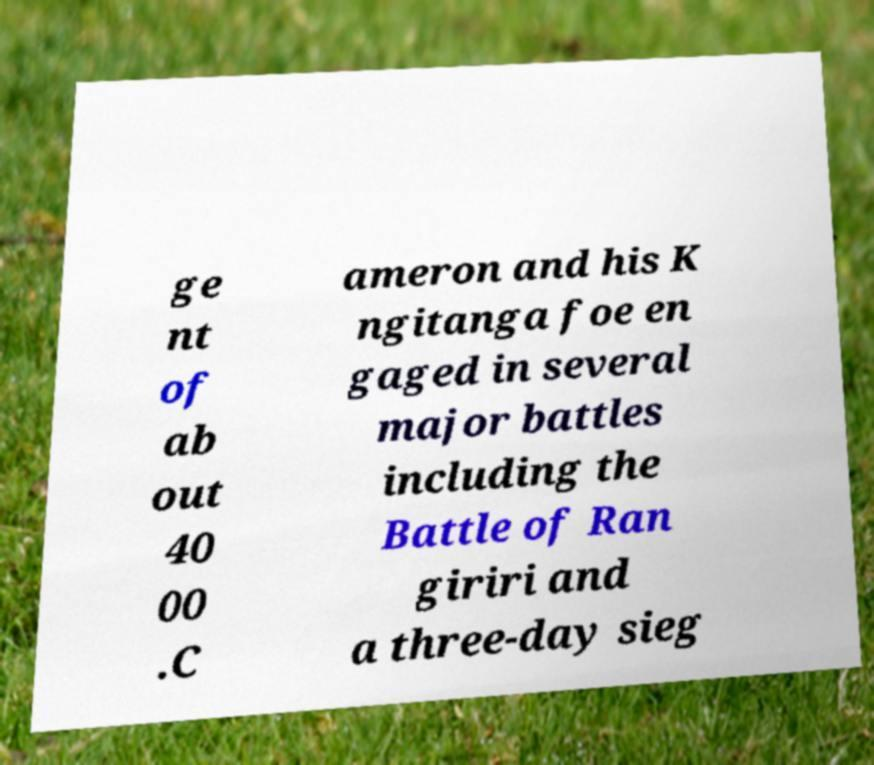I need the written content from this picture converted into text. Can you do that? ge nt of ab out 40 00 .C ameron and his K ngitanga foe en gaged in several major battles including the Battle of Ran giriri and a three-day sieg 